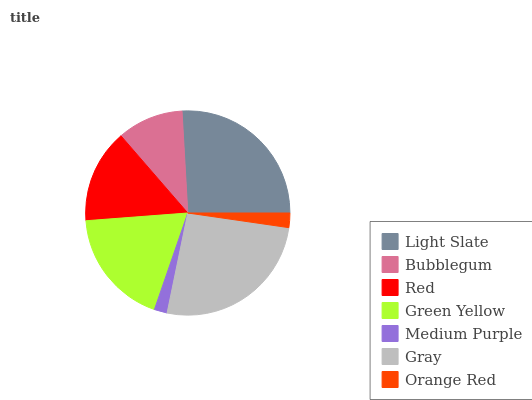Is Medium Purple the minimum?
Answer yes or no. Yes. Is Gray the maximum?
Answer yes or no. Yes. Is Bubblegum the minimum?
Answer yes or no. No. Is Bubblegum the maximum?
Answer yes or no. No. Is Light Slate greater than Bubblegum?
Answer yes or no. Yes. Is Bubblegum less than Light Slate?
Answer yes or no. Yes. Is Bubblegum greater than Light Slate?
Answer yes or no. No. Is Light Slate less than Bubblegum?
Answer yes or no. No. Is Red the high median?
Answer yes or no. Yes. Is Red the low median?
Answer yes or no. Yes. Is Green Yellow the high median?
Answer yes or no. No. Is Medium Purple the low median?
Answer yes or no. No. 